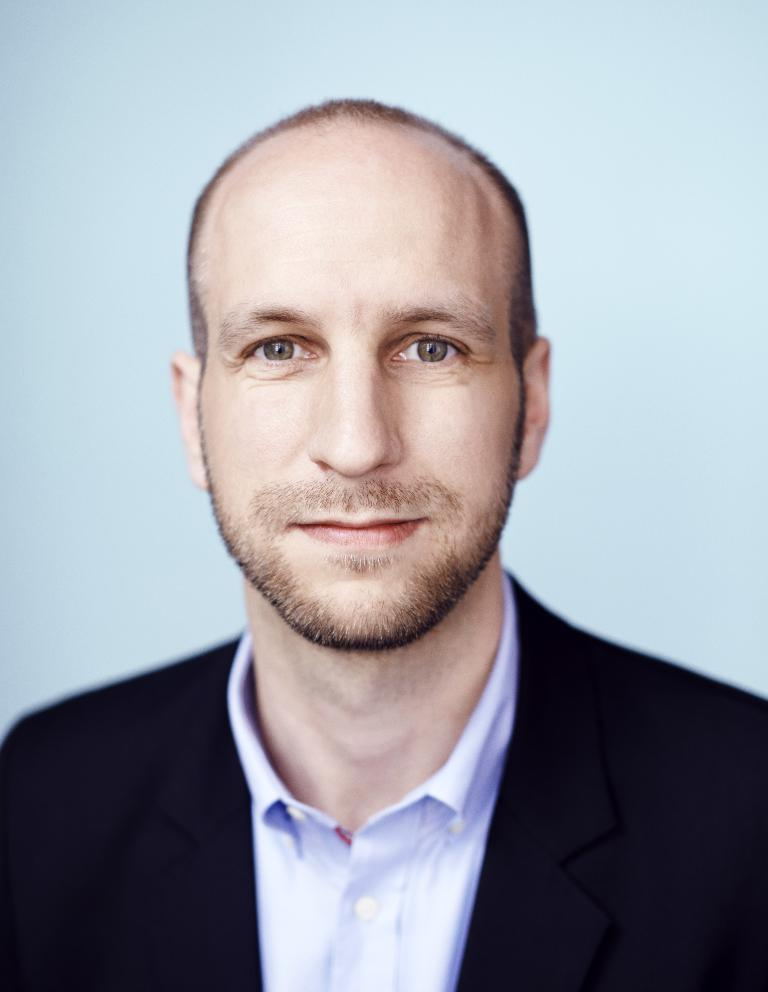What type of photograph is in the image? There is a passport size photograph in the image. What is the person in the photograph wearing on their upper body? The person in the photograph is wearing a white shirt and a black blazer. What type of toy can be seen in the person's hand in the image? There is no toy present in the image; the person is not holding anything. 